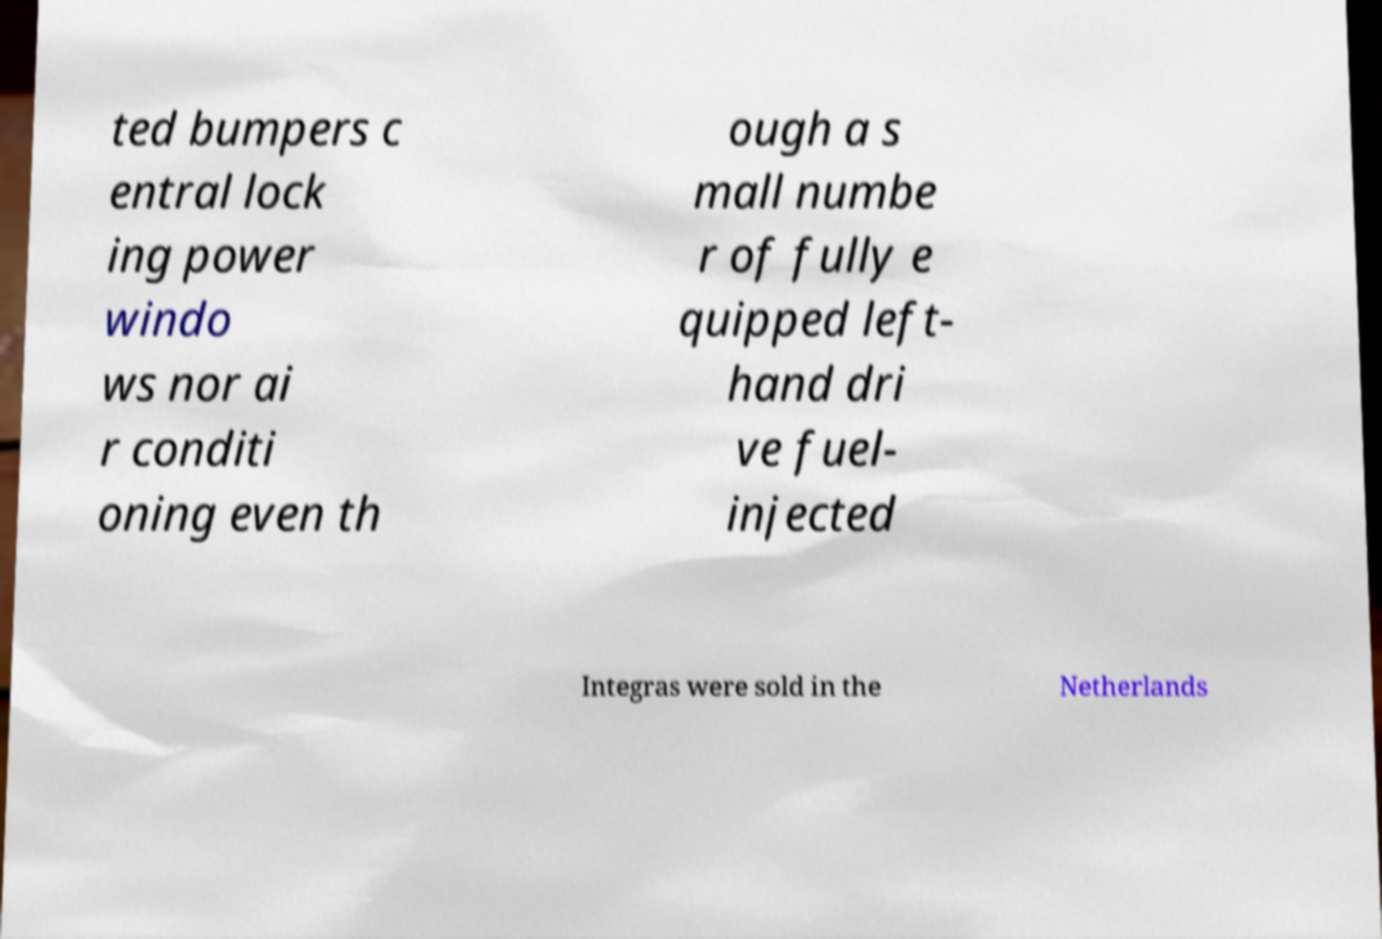Can you read and provide the text displayed in the image?This photo seems to have some interesting text. Can you extract and type it out for me? ted bumpers c entral lock ing power windo ws nor ai r conditi oning even th ough a s mall numbe r of fully e quipped left- hand dri ve fuel- injected Integras were sold in the Netherlands 